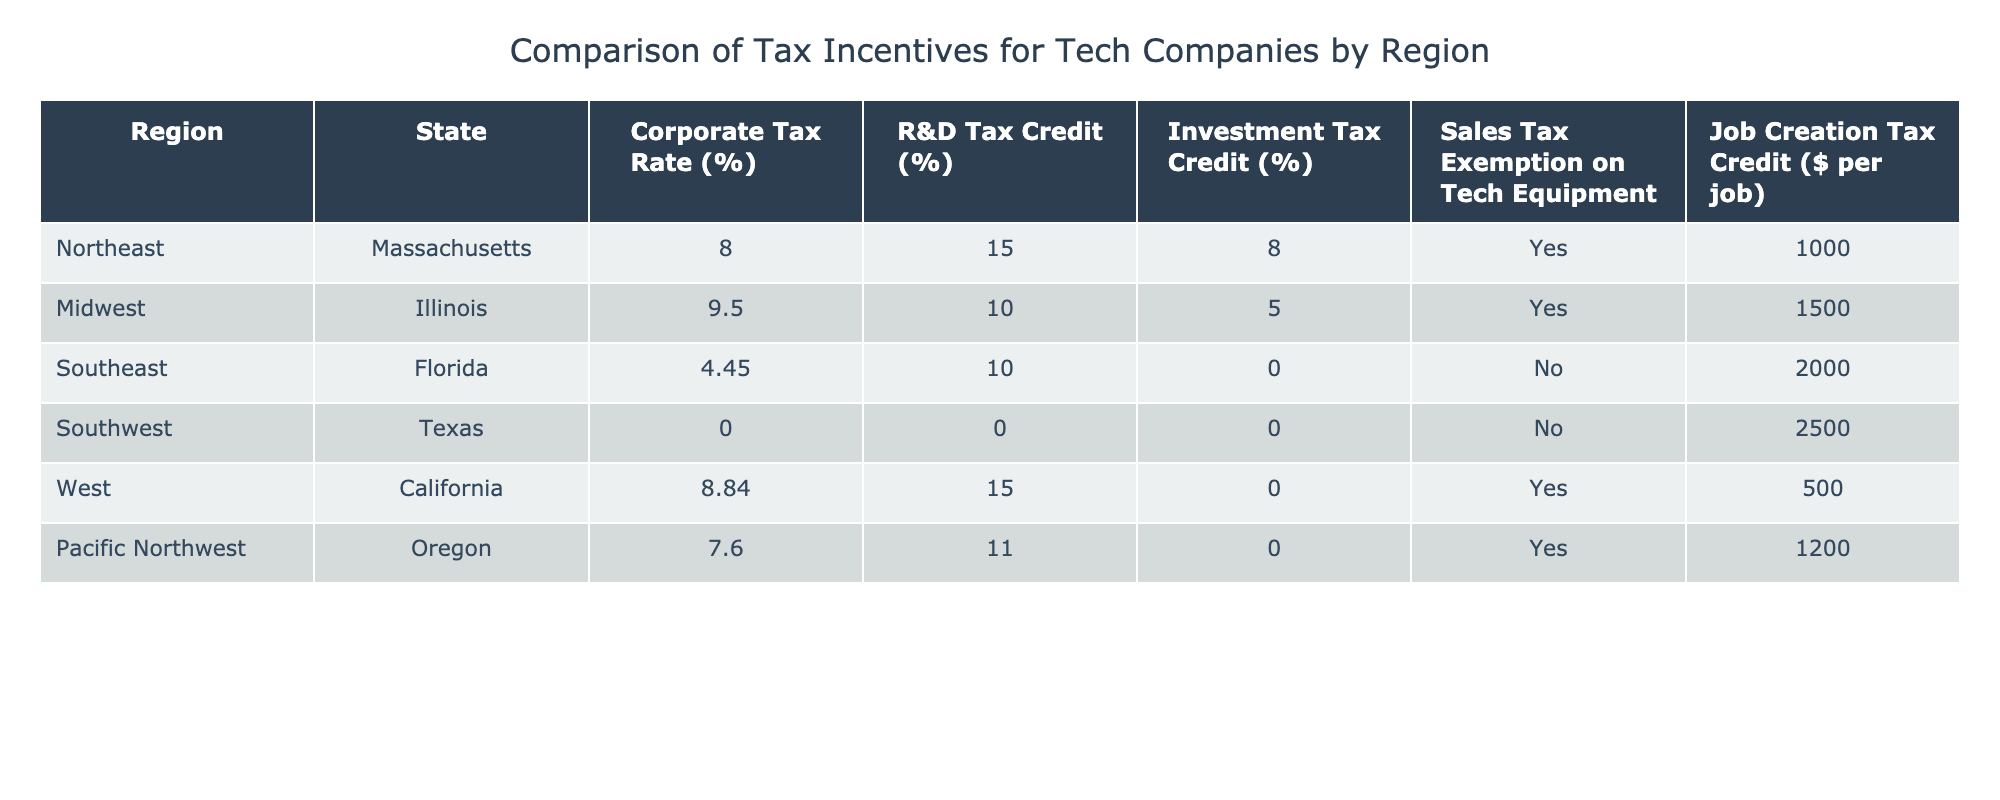What is the corporate tax rate in Illinois? The corporate tax rate for Illinois is explicitly listed in the table under the Corporate Tax Rate column.
Answer: 9.50% Which region offers the highest job creation tax credit? The Southwest region (Texas) offers the highest job creation tax credit, which is $2500 per job, as per the values in the Job Creation Tax Credit column.
Answer: $2500 Is there a sales tax exemption on tech equipment in Oregon? Checking the Sales Tax Exemption on Tech Equipment column for Oregon shows a 'Yes' value, indicating there is an exemption.
Answer: Yes What is the average R&D tax credit percentage across all regions? The R&D tax credits are as follows: Massachusetts (15), Illinois (10), Florida (10), Texas (0), California (15), Oregon (11). Adding them gives 15 + 10 + 10 + 0 + 15 + 11 = 61. There are 6 regions, so the average is 61 / 6 ≈ 10.17.
Answer: 10.17% Which region has the lowest corporate tax rate and what is it? The Southwest region (Texas) has the lowest corporate tax rate at 0.00%, as seen in the Corporate Tax Rate column.
Answer: 0.00% How does the R&D tax credit in Massachusetts compare to that in California? Massachusetts has a R&D tax credit of 15%, while California also has a R&D tax credit of 15%. The comparison shows they are equal.
Answer: Equal What is the difference in job creation tax credits between Florida and Illinois? The job creation tax credit for Florida is $2000, and for Illinois, it is $1500. The difference is calculated as 2000 - 1500 = 500.
Answer: $500 Which state has a sales tax exemption on tech equipment but a lower corporate tax rate than Illinois? Florida has no sales tax exemption on tech equipment (No), and Texas has a sales tax exemption (No) with a corporate tax rate of 0.00%, which is lower than Illinois's 9.50%. However, only Texas qualifies with the exemption condition applied.
Answer: Texas In terms of overall incentives for tech companies, which region appears the most favorable? Analyzing the combined aspects of corporate tax rate, job creation tax credit, and availability of sales tax exemptions suggests Texas is the most favorable due to its lowest corporate tax rate (0.00%), a high job creation tax credit ($2500), and absence of sales tax.
Answer: Texas 